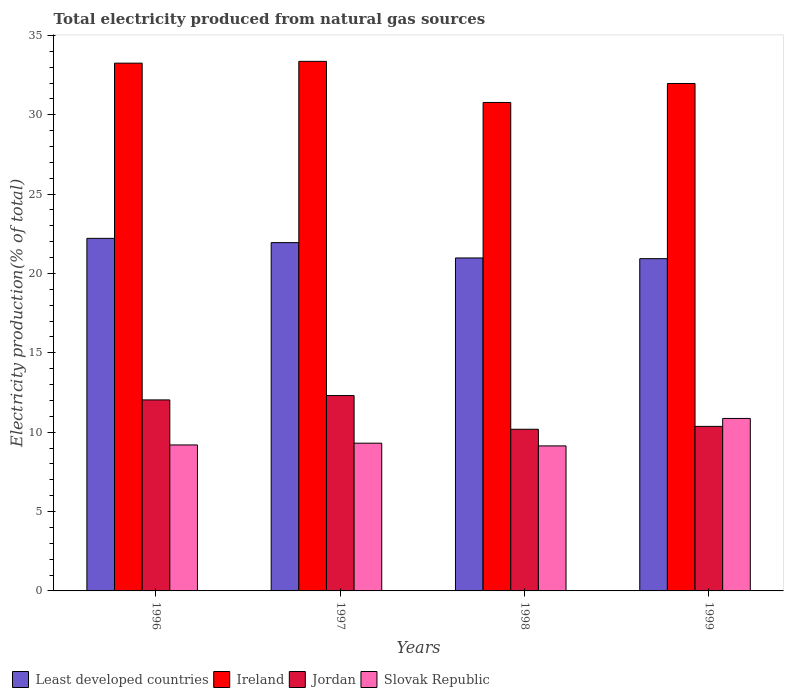How many groups of bars are there?
Provide a succinct answer. 4. Are the number of bars on each tick of the X-axis equal?
Offer a very short reply. Yes. What is the label of the 1st group of bars from the left?
Offer a very short reply. 1996. What is the total electricity produced in Ireland in 1997?
Offer a terse response. 33.36. Across all years, what is the maximum total electricity produced in Ireland?
Make the answer very short. 33.36. Across all years, what is the minimum total electricity produced in Ireland?
Provide a succinct answer. 30.77. In which year was the total electricity produced in Ireland minimum?
Your answer should be compact. 1998. What is the total total electricity produced in Jordan in the graph?
Provide a succinct answer. 44.89. What is the difference between the total electricity produced in Ireland in 1996 and that in 1999?
Offer a very short reply. 1.28. What is the difference between the total electricity produced in Least developed countries in 1998 and the total electricity produced in Ireland in 1999?
Provide a short and direct response. -10.99. What is the average total electricity produced in Ireland per year?
Give a very brief answer. 32.34. In the year 1999, what is the difference between the total electricity produced in Slovak Republic and total electricity produced in Jordan?
Your response must be concise. 0.5. What is the ratio of the total electricity produced in Least developed countries in 1996 to that in 1999?
Offer a very short reply. 1.06. What is the difference between the highest and the second highest total electricity produced in Jordan?
Make the answer very short. 0.27. What is the difference between the highest and the lowest total electricity produced in Slovak Republic?
Offer a very short reply. 1.73. In how many years, is the total electricity produced in Ireland greater than the average total electricity produced in Ireland taken over all years?
Keep it short and to the point. 2. What does the 1st bar from the left in 1996 represents?
Your response must be concise. Least developed countries. What does the 1st bar from the right in 1996 represents?
Offer a very short reply. Slovak Republic. Is it the case that in every year, the sum of the total electricity produced in Least developed countries and total electricity produced in Slovak Republic is greater than the total electricity produced in Ireland?
Your answer should be very brief. No. Does the graph contain any zero values?
Provide a short and direct response. No. Where does the legend appear in the graph?
Provide a succinct answer. Bottom left. What is the title of the graph?
Provide a short and direct response. Total electricity produced from natural gas sources. Does "Uganda" appear as one of the legend labels in the graph?
Offer a very short reply. No. What is the label or title of the X-axis?
Offer a terse response. Years. What is the Electricity production(% of total) in Least developed countries in 1996?
Provide a succinct answer. 22.21. What is the Electricity production(% of total) of Ireland in 1996?
Your response must be concise. 33.25. What is the Electricity production(% of total) of Jordan in 1996?
Ensure brevity in your answer.  12.03. What is the Electricity production(% of total) of Slovak Republic in 1996?
Ensure brevity in your answer.  9.2. What is the Electricity production(% of total) in Least developed countries in 1997?
Keep it short and to the point. 21.94. What is the Electricity production(% of total) of Ireland in 1997?
Keep it short and to the point. 33.36. What is the Electricity production(% of total) in Jordan in 1997?
Offer a terse response. 12.31. What is the Electricity production(% of total) of Slovak Republic in 1997?
Your answer should be compact. 9.31. What is the Electricity production(% of total) of Least developed countries in 1998?
Provide a short and direct response. 20.98. What is the Electricity production(% of total) in Ireland in 1998?
Make the answer very short. 30.77. What is the Electricity production(% of total) of Jordan in 1998?
Your answer should be very brief. 10.19. What is the Electricity production(% of total) in Slovak Republic in 1998?
Your answer should be compact. 9.14. What is the Electricity production(% of total) of Least developed countries in 1999?
Ensure brevity in your answer.  20.93. What is the Electricity production(% of total) in Ireland in 1999?
Keep it short and to the point. 31.97. What is the Electricity production(% of total) of Jordan in 1999?
Offer a very short reply. 10.37. What is the Electricity production(% of total) in Slovak Republic in 1999?
Provide a short and direct response. 10.87. Across all years, what is the maximum Electricity production(% of total) in Least developed countries?
Your answer should be very brief. 22.21. Across all years, what is the maximum Electricity production(% of total) of Ireland?
Your answer should be compact. 33.36. Across all years, what is the maximum Electricity production(% of total) of Jordan?
Your response must be concise. 12.31. Across all years, what is the maximum Electricity production(% of total) of Slovak Republic?
Ensure brevity in your answer.  10.87. Across all years, what is the minimum Electricity production(% of total) in Least developed countries?
Your answer should be very brief. 20.93. Across all years, what is the minimum Electricity production(% of total) in Ireland?
Offer a terse response. 30.77. Across all years, what is the minimum Electricity production(% of total) in Jordan?
Ensure brevity in your answer.  10.19. Across all years, what is the minimum Electricity production(% of total) in Slovak Republic?
Keep it short and to the point. 9.14. What is the total Electricity production(% of total) in Least developed countries in the graph?
Give a very brief answer. 86.07. What is the total Electricity production(% of total) in Ireland in the graph?
Make the answer very short. 129.36. What is the total Electricity production(% of total) in Jordan in the graph?
Make the answer very short. 44.89. What is the total Electricity production(% of total) in Slovak Republic in the graph?
Offer a terse response. 38.51. What is the difference between the Electricity production(% of total) in Least developed countries in 1996 and that in 1997?
Offer a terse response. 0.27. What is the difference between the Electricity production(% of total) of Ireland in 1996 and that in 1997?
Offer a terse response. -0.11. What is the difference between the Electricity production(% of total) in Jordan in 1996 and that in 1997?
Your answer should be compact. -0.27. What is the difference between the Electricity production(% of total) of Slovak Republic in 1996 and that in 1997?
Make the answer very short. -0.11. What is the difference between the Electricity production(% of total) of Least developed countries in 1996 and that in 1998?
Offer a very short reply. 1.23. What is the difference between the Electricity production(% of total) of Ireland in 1996 and that in 1998?
Make the answer very short. 2.48. What is the difference between the Electricity production(% of total) of Jordan in 1996 and that in 1998?
Keep it short and to the point. 1.85. What is the difference between the Electricity production(% of total) of Slovak Republic in 1996 and that in 1998?
Provide a succinct answer. 0.06. What is the difference between the Electricity production(% of total) of Least developed countries in 1996 and that in 1999?
Offer a terse response. 1.28. What is the difference between the Electricity production(% of total) of Ireland in 1996 and that in 1999?
Make the answer very short. 1.28. What is the difference between the Electricity production(% of total) of Jordan in 1996 and that in 1999?
Offer a terse response. 1.67. What is the difference between the Electricity production(% of total) in Slovak Republic in 1996 and that in 1999?
Provide a short and direct response. -1.67. What is the difference between the Electricity production(% of total) of Least developed countries in 1997 and that in 1998?
Offer a terse response. 0.97. What is the difference between the Electricity production(% of total) in Ireland in 1997 and that in 1998?
Keep it short and to the point. 2.59. What is the difference between the Electricity production(% of total) of Jordan in 1997 and that in 1998?
Make the answer very short. 2.12. What is the difference between the Electricity production(% of total) in Slovak Republic in 1997 and that in 1998?
Ensure brevity in your answer.  0.17. What is the difference between the Electricity production(% of total) of Least developed countries in 1997 and that in 1999?
Your answer should be very brief. 1.01. What is the difference between the Electricity production(% of total) of Ireland in 1997 and that in 1999?
Make the answer very short. 1.4. What is the difference between the Electricity production(% of total) in Jordan in 1997 and that in 1999?
Keep it short and to the point. 1.94. What is the difference between the Electricity production(% of total) in Slovak Republic in 1997 and that in 1999?
Give a very brief answer. -1.56. What is the difference between the Electricity production(% of total) in Least developed countries in 1998 and that in 1999?
Provide a succinct answer. 0.04. What is the difference between the Electricity production(% of total) in Ireland in 1998 and that in 1999?
Ensure brevity in your answer.  -1.19. What is the difference between the Electricity production(% of total) of Jordan in 1998 and that in 1999?
Your answer should be compact. -0.18. What is the difference between the Electricity production(% of total) in Slovak Republic in 1998 and that in 1999?
Make the answer very short. -1.73. What is the difference between the Electricity production(% of total) of Least developed countries in 1996 and the Electricity production(% of total) of Ireland in 1997?
Your answer should be compact. -11.15. What is the difference between the Electricity production(% of total) of Least developed countries in 1996 and the Electricity production(% of total) of Jordan in 1997?
Provide a short and direct response. 9.9. What is the difference between the Electricity production(% of total) in Least developed countries in 1996 and the Electricity production(% of total) in Slovak Republic in 1997?
Ensure brevity in your answer.  12.9. What is the difference between the Electricity production(% of total) in Ireland in 1996 and the Electricity production(% of total) in Jordan in 1997?
Keep it short and to the point. 20.94. What is the difference between the Electricity production(% of total) of Ireland in 1996 and the Electricity production(% of total) of Slovak Republic in 1997?
Keep it short and to the point. 23.94. What is the difference between the Electricity production(% of total) of Jordan in 1996 and the Electricity production(% of total) of Slovak Republic in 1997?
Keep it short and to the point. 2.73. What is the difference between the Electricity production(% of total) in Least developed countries in 1996 and the Electricity production(% of total) in Ireland in 1998?
Offer a very short reply. -8.56. What is the difference between the Electricity production(% of total) in Least developed countries in 1996 and the Electricity production(% of total) in Jordan in 1998?
Offer a terse response. 12.03. What is the difference between the Electricity production(% of total) of Least developed countries in 1996 and the Electricity production(% of total) of Slovak Republic in 1998?
Keep it short and to the point. 13.08. What is the difference between the Electricity production(% of total) in Ireland in 1996 and the Electricity production(% of total) in Jordan in 1998?
Provide a succinct answer. 23.07. What is the difference between the Electricity production(% of total) in Ireland in 1996 and the Electricity production(% of total) in Slovak Republic in 1998?
Provide a short and direct response. 24.11. What is the difference between the Electricity production(% of total) in Jordan in 1996 and the Electricity production(% of total) in Slovak Republic in 1998?
Your response must be concise. 2.9. What is the difference between the Electricity production(% of total) of Least developed countries in 1996 and the Electricity production(% of total) of Ireland in 1999?
Offer a very short reply. -9.76. What is the difference between the Electricity production(% of total) of Least developed countries in 1996 and the Electricity production(% of total) of Jordan in 1999?
Provide a succinct answer. 11.85. What is the difference between the Electricity production(% of total) of Least developed countries in 1996 and the Electricity production(% of total) of Slovak Republic in 1999?
Make the answer very short. 11.35. What is the difference between the Electricity production(% of total) of Ireland in 1996 and the Electricity production(% of total) of Jordan in 1999?
Keep it short and to the point. 22.88. What is the difference between the Electricity production(% of total) of Ireland in 1996 and the Electricity production(% of total) of Slovak Republic in 1999?
Your answer should be very brief. 22.38. What is the difference between the Electricity production(% of total) of Jordan in 1996 and the Electricity production(% of total) of Slovak Republic in 1999?
Keep it short and to the point. 1.17. What is the difference between the Electricity production(% of total) in Least developed countries in 1997 and the Electricity production(% of total) in Ireland in 1998?
Make the answer very short. -8.83. What is the difference between the Electricity production(% of total) of Least developed countries in 1997 and the Electricity production(% of total) of Jordan in 1998?
Provide a short and direct response. 11.76. What is the difference between the Electricity production(% of total) in Least developed countries in 1997 and the Electricity production(% of total) in Slovak Republic in 1998?
Provide a short and direct response. 12.81. What is the difference between the Electricity production(% of total) of Ireland in 1997 and the Electricity production(% of total) of Jordan in 1998?
Provide a short and direct response. 23.18. What is the difference between the Electricity production(% of total) in Ireland in 1997 and the Electricity production(% of total) in Slovak Republic in 1998?
Ensure brevity in your answer.  24.23. What is the difference between the Electricity production(% of total) in Jordan in 1997 and the Electricity production(% of total) in Slovak Republic in 1998?
Your response must be concise. 3.17. What is the difference between the Electricity production(% of total) of Least developed countries in 1997 and the Electricity production(% of total) of Ireland in 1999?
Keep it short and to the point. -10.02. What is the difference between the Electricity production(% of total) of Least developed countries in 1997 and the Electricity production(% of total) of Jordan in 1999?
Provide a succinct answer. 11.58. What is the difference between the Electricity production(% of total) in Least developed countries in 1997 and the Electricity production(% of total) in Slovak Republic in 1999?
Your answer should be very brief. 11.08. What is the difference between the Electricity production(% of total) in Ireland in 1997 and the Electricity production(% of total) in Jordan in 1999?
Keep it short and to the point. 23. What is the difference between the Electricity production(% of total) of Ireland in 1997 and the Electricity production(% of total) of Slovak Republic in 1999?
Offer a terse response. 22.5. What is the difference between the Electricity production(% of total) of Jordan in 1997 and the Electricity production(% of total) of Slovak Republic in 1999?
Keep it short and to the point. 1.44. What is the difference between the Electricity production(% of total) in Least developed countries in 1998 and the Electricity production(% of total) in Ireland in 1999?
Keep it short and to the point. -10.99. What is the difference between the Electricity production(% of total) of Least developed countries in 1998 and the Electricity production(% of total) of Jordan in 1999?
Offer a very short reply. 10.61. What is the difference between the Electricity production(% of total) in Least developed countries in 1998 and the Electricity production(% of total) in Slovak Republic in 1999?
Make the answer very short. 10.11. What is the difference between the Electricity production(% of total) in Ireland in 1998 and the Electricity production(% of total) in Jordan in 1999?
Make the answer very short. 20.41. What is the difference between the Electricity production(% of total) in Ireland in 1998 and the Electricity production(% of total) in Slovak Republic in 1999?
Provide a short and direct response. 19.91. What is the difference between the Electricity production(% of total) of Jordan in 1998 and the Electricity production(% of total) of Slovak Republic in 1999?
Make the answer very short. -0.68. What is the average Electricity production(% of total) in Least developed countries per year?
Offer a terse response. 21.52. What is the average Electricity production(% of total) in Ireland per year?
Offer a very short reply. 32.34. What is the average Electricity production(% of total) of Jordan per year?
Your answer should be very brief. 11.22. What is the average Electricity production(% of total) in Slovak Republic per year?
Your response must be concise. 9.63. In the year 1996, what is the difference between the Electricity production(% of total) in Least developed countries and Electricity production(% of total) in Ireland?
Offer a terse response. -11.04. In the year 1996, what is the difference between the Electricity production(% of total) in Least developed countries and Electricity production(% of total) in Jordan?
Provide a short and direct response. 10.18. In the year 1996, what is the difference between the Electricity production(% of total) in Least developed countries and Electricity production(% of total) in Slovak Republic?
Your response must be concise. 13.02. In the year 1996, what is the difference between the Electricity production(% of total) of Ireland and Electricity production(% of total) of Jordan?
Your response must be concise. 21.22. In the year 1996, what is the difference between the Electricity production(% of total) in Ireland and Electricity production(% of total) in Slovak Republic?
Make the answer very short. 24.05. In the year 1996, what is the difference between the Electricity production(% of total) of Jordan and Electricity production(% of total) of Slovak Republic?
Give a very brief answer. 2.84. In the year 1997, what is the difference between the Electricity production(% of total) in Least developed countries and Electricity production(% of total) in Ireland?
Ensure brevity in your answer.  -11.42. In the year 1997, what is the difference between the Electricity production(% of total) in Least developed countries and Electricity production(% of total) in Jordan?
Offer a very short reply. 9.64. In the year 1997, what is the difference between the Electricity production(% of total) of Least developed countries and Electricity production(% of total) of Slovak Republic?
Give a very brief answer. 12.64. In the year 1997, what is the difference between the Electricity production(% of total) in Ireland and Electricity production(% of total) in Jordan?
Your answer should be very brief. 21.06. In the year 1997, what is the difference between the Electricity production(% of total) of Ireland and Electricity production(% of total) of Slovak Republic?
Provide a succinct answer. 24.06. In the year 1997, what is the difference between the Electricity production(% of total) of Jordan and Electricity production(% of total) of Slovak Republic?
Provide a succinct answer. 3. In the year 1998, what is the difference between the Electricity production(% of total) in Least developed countries and Electricity production(% of total) in Ireland?
Give a very brief answer. -9.8. In the year 1998, what is the difference between the Electricity production(% of total) in Least developed countries and Electricity production(% of total) in Jordan?
Offer a terse response. 10.79. In the year 1998, what is the difference between the Electricity production(% of total) in Least developed countries and Electricity production(% of total) in Slovak Republic?
Offer a very short reply. 11.84. In the year 1998, what is the difference between the Electricity production(% of total) of Ireland and Electricity production(% of total) of Jordan?
Offer a very short reply. 20.59. In the year 1998, what is the difference between the Electricity production(% of total) in Ireland and Electricity production(% of total) in Slovak Republic?
Your answer should be compact. 21.64. In the year 1998, what is the difference between the Electricity production(% of total) in Jordan and Electricity production(% of total) in Slovak Republic?
Provide a succinct answer. 1.05. In the year 1999, what is the difference between the Electricity production(% of total) in Least developed countries and Electricity production(% of total) in Ireland?
Give a very brief answer. -11.04. In the year 1999, what is the difference between the Electricity production(% of total) of Least developed countries and Electricity production(% of total) of Jordan?
Offer a very short reply. 10.57. In the year 1999, what is the difference between the Electricity production(% of total) in Least developed countries and Electricity production(% of total) in Slovak Republic?
Your answer should be very brief. 10.07. In the year 1999, what is the difference between the Electricity production(% of total) in Ireland and Electricity production(% of total) in Jordan?
Give a very brief answer. 21.6. In the year 1999, what is the difference between the Electricity production(% of total) of Ireland and Electricity production(% of total) of Slovak Republic?
Provide a short and direct response. 21.1. In the year 1999, what is the difference between the Electricity production(% of total) of Jordan and Electricity production(% of total) of Slovak Republic?
Make the answer very short. -0.5. What is the ratio of the Electricity production(% of total) in Least developed countries in 1996 to that in 1997?
Ensure brevity in your answer.  1.01. What is the ratio of the Electricity production(% of total) in Jordan in 1996 to that in 1997?
Give a very brief answer. 0.98. What is the ratio of the Electricity production(% of total) of Slovak Republic in 1996 to that in 1997?
Make the answer very short. 0.99. What is the ratio of the Electricity production(% of total) of Least developed countries in 1996 to that in 1998?
Your answer should be very brief. 1.06. What is the ratio of the Electricity production(% of total) of Ireland in 1996 to that in 1998?
Your response must be concise. 1.08. What is the ratio of the Electricity production(% of total) in Jordan in 1996 to that in 1998?
Offer a very short reply. 1.18. What is the ratio of the Electricity production(% of total) of Slovak Republic in 1996 to that in 1998?
Your response must be concise. 1.01. What is the ratio of the Electricity production(% of total) in Least developed countries in 1996 to that in 1999?
Keep it short and to the point. 1.06. What is the ratio of the Electricity production(% of total) in Ireland in 1996 to that in 1999?
Ensure brevity in your answer.  1.04. What is the ratio of the Electricity production(% of total) of Jordan in 1996 to that in 1999?
Your answer should be compact. 1.16. What is the ratio of the Electricity production(% of total) in Slovak Republic in 1996 to that in 1999?
Keep it short and to the point. 0.85. What is the ratio of the Electricity production(% of total) in Least developed countries in 1997 to that in 1998?
Provide a succinct answer. 1.05. What is the ratio of the Electricity production(% of total) in Ireland in 1997 to that in 1998?
Keep it short and to the point. 1.08. What is the ratio of the Electricity production(% of total) in Jordan in 1997 to that in 1998?
Give a very brief answer. 1.21. What is the ratio of the Electricity production(% of total) in Slovak Republic in 1997 to that in 1998?
Provide a succinct answer. 1.02. What is the ratio of the Electricity production(% of total) in Least developed countries in 1997 to that in 1999?
Provide a succinct answer. 1.05. What is the ratio of the Electricity production(% of total) in Ireland in 1997 to that in 1999?
Your answer should be very brief. 1.04. What is the ratio of the Electricity production(% of total) in Jordan in 1997 to that in 1999?
Ensure brevity in your answer.  1.19. What is the ratio of the Electricity production(% of total) in Slovak Republic in 1997 to that in 1999?
Your response must be concise. 0.86. What is the ratio of the Electricity production(% of total) of Ireland in 1998 to that in 1999?
Provide a succinct answer. 0.96. What is the ratio of the Electricity production(% of total) in Jordan in 1998 to that in 1999?
Ensure brevity in your answer.  0.98. What is the ratio of the Electricity production(% of total) of Slovak Republic in 1998 to that in 1999?
Ensure brevity in your answer.  0.84. What is the difference between the highest and the second highest Electricity production(% of total) in Least developed countries?
Offer a terse response. 0.27. What is the difference between the highest and the second highest Electricity production(% of total) in Ireland?
Give a very brief answer. 0.11. What is the difference between the highest and the second highest Electricity production(% of total) of Jordan?
Provide a short and direct response. 0.27. What is the difference between the highest and the second highest Electricity production(% of total) in Slovak Republic?
Your answer should be very brief. 1.56. What is the difference between the highest and the lowest Electricity production(% of total) of Least developed countries?
Offer a very short reply. 1.28. What is the difference between the highest and the lowest Electricity production(% of total) in Ireland?
Provide a short and direct response. 2.59. What is the difference between the highest and the lowest Electricity production(% of total) of Jordan?
Your answer should be compact. 2.12. What is the difference between the highest and the lowest Electricity production(% of total) of Slovak Republic?
Provide a short and direct response. 1.73. 